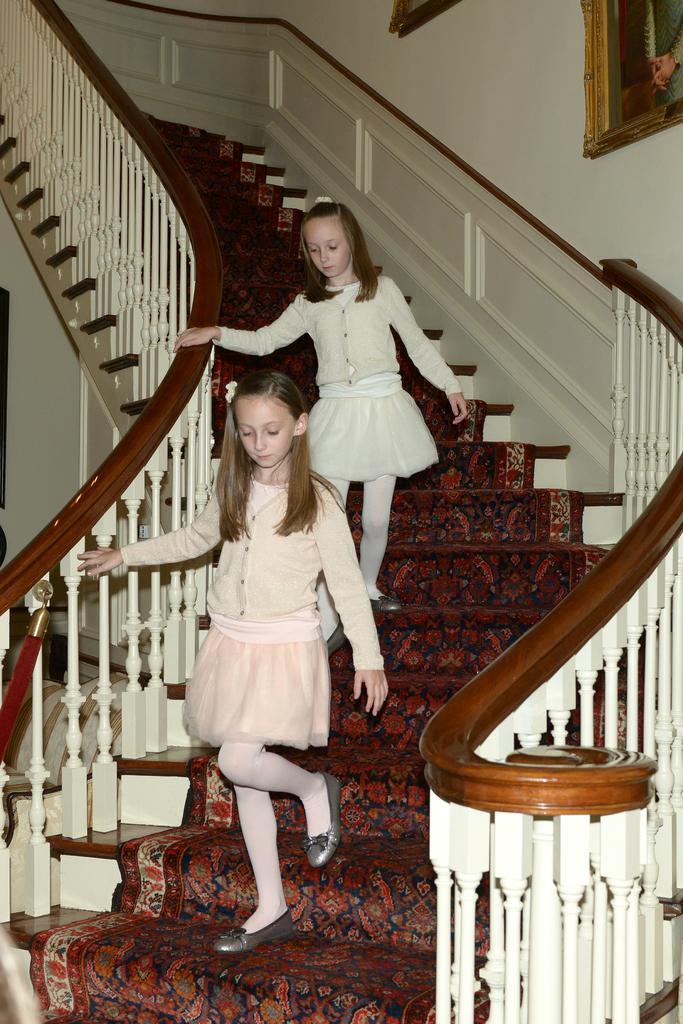Describe this image in one or two sentences. In this image we can see there are two persons walking on the stairs and there is the carpet on the stairs. And at the sides we can see the railing. And there are photo frames attached to the wall. 